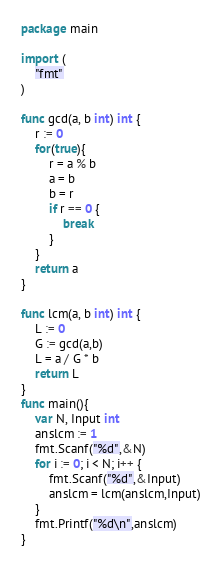<code> <loc_0><loc_0><loc_500><loc_500><_Go_>package main

import (
	"fmt"
)

func gcd(a, b int) int {
	r := 0
	for(true){
		r = a % b
		a = b
		b = r
		if r == 0 {
			break 
		}
	}
	return a	
}

func lcm(a, b int) int {
	L := 0
	G := gcd(a,b)
	L = a / G * b
	return L
}
func main(){
	var N, Input int
	anslcm := 1
	fmt.Scanf("%d",&N)
	for i := 0; i < N; i++ {
		fmt.Scanf("%d",&Input)
		anslcm = lcm(anslcm,Input)
	}
	fmt.Printf("%d\n",anslcm)
}
</code> 